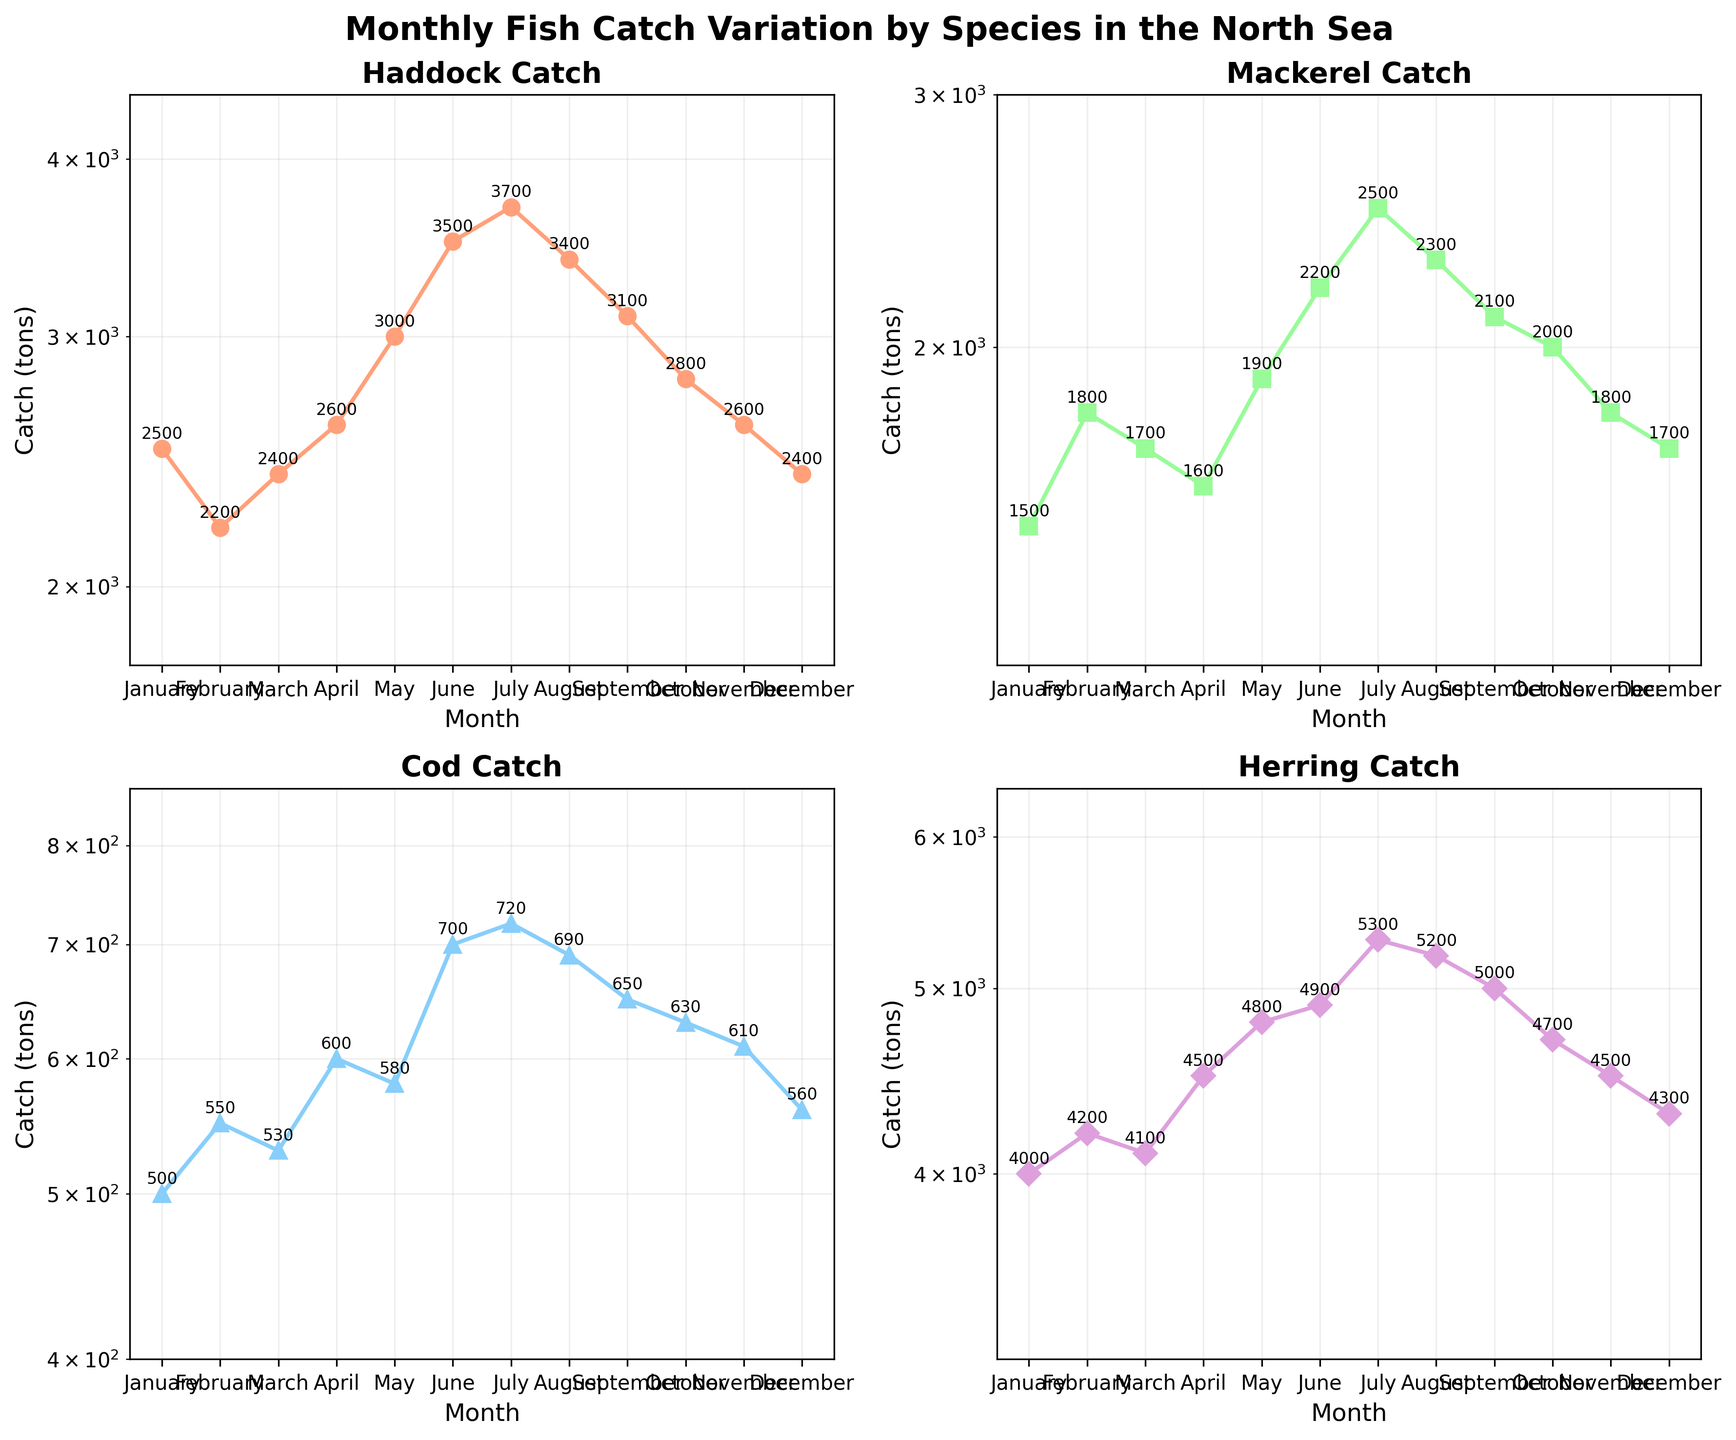Which species has the highest catch in January? The subplots depict the catch for each species by month. In January, comparing the values next to the markers, Herring has the highest catch at 4000 tons.
Answer: Herring Cia mheud sgèile-log air an tuagh-y san ìomhaigh? Tha gach tuslach log air an tuagh-y. Bidh gach sgèile nas motha na 1,000 airson 10,000
Answer: log Which month has the lowest catch for Mackerel? Checking the Mackerel subplot, the lowest catch is in April with 1600 tons.
Answer: April Which species shows the most similar catch values throughout the year? By visual inspection of the plotted lines, Cod has the catch values most closely clustered together.
Answer: Cod What’s the average catch for Haddock over the year? Summing the catches for all months and dividing by 12: (2500 + 2200 + 2400 + 2600 + 3000 + 3500 + 3700 + 3400 + 3100 + 2800 + 2600 + 2400) / 12 = 2875 tons.
Answer: 2875 tons In which month does the difference between Haddock and Herring catch appear the smallest? By analyzing the subplot for each month, in January Haddock is 2500 tons and Herring is 4000 tons, making their difference 1500 tons. This appears to be the smallest visual difference compared to other months.
Answer: January Is there any month where the Mackerel catch is greater than the Herring catch? For Mackerel, the catch never exceeds the Herring catch in any of the months according to the subplot visualization.
Answer: No Which month shows the highest catch variation for Cod? By looking at the plot, July has the highest catch with 720 tons and therefore the highest variation, as other months have lower values.
Answer: July What’s the range of the Herring catch over the year? The minimum catch for Herring is 4000 tons in January and the maximum is 5300 tons in July. The range is 5300 - 4000 = 1300 tons.
Answer: 1300 tons In which month does the catch of Herring first exceed 5000 tons? Herring exceeds 5000 tons for the first time in July, with the plot showing 5300 tons in that month.
Answer: July 